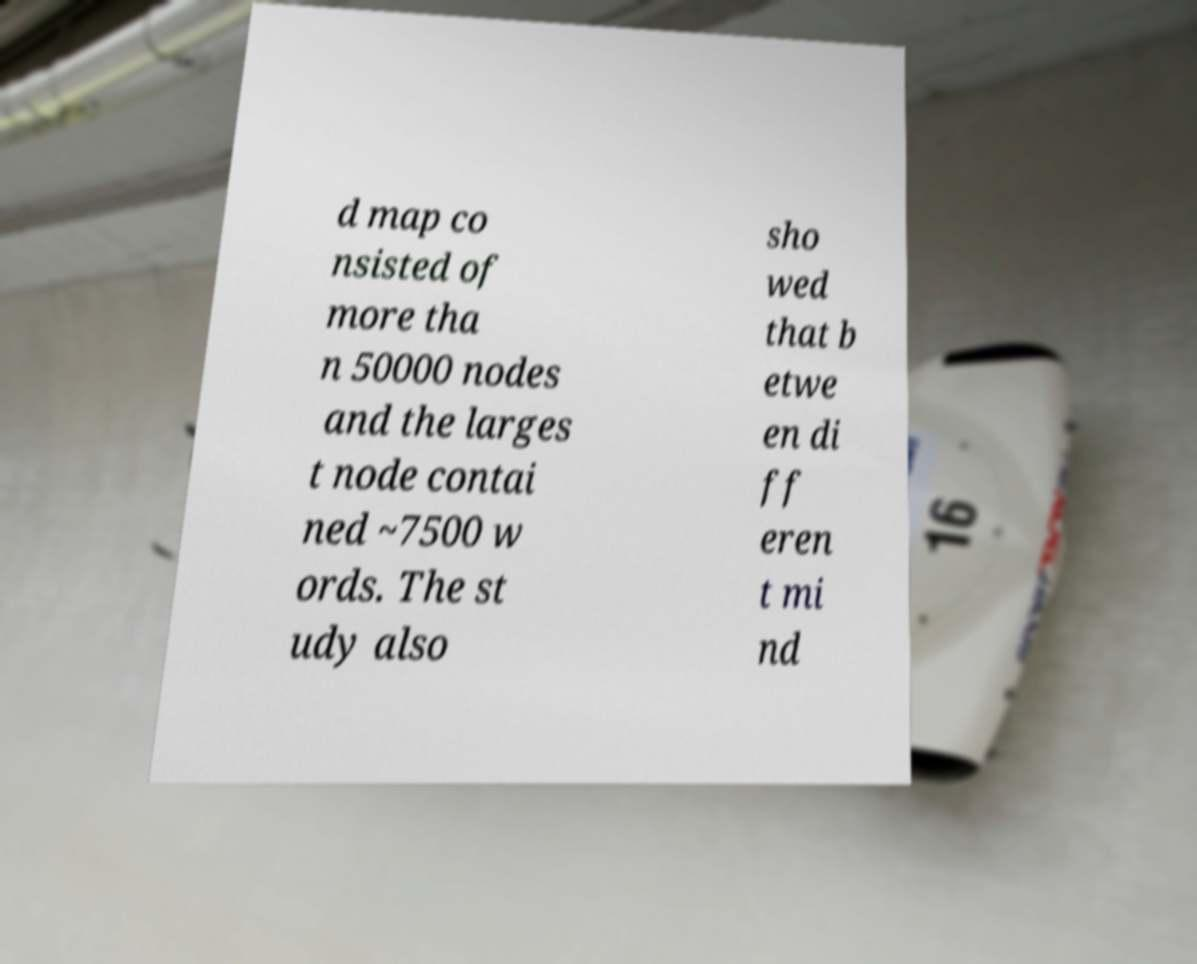Can you read and provide the text displayed in the image?This photo seems to have some interesting text. Can you extract and type it out for me? d map co nsisted of more tha n 50000 nodes and the larges t node contai ned ~7500 w ords. The st udy also sho wed that b etwe en di ff eren t mi nd 